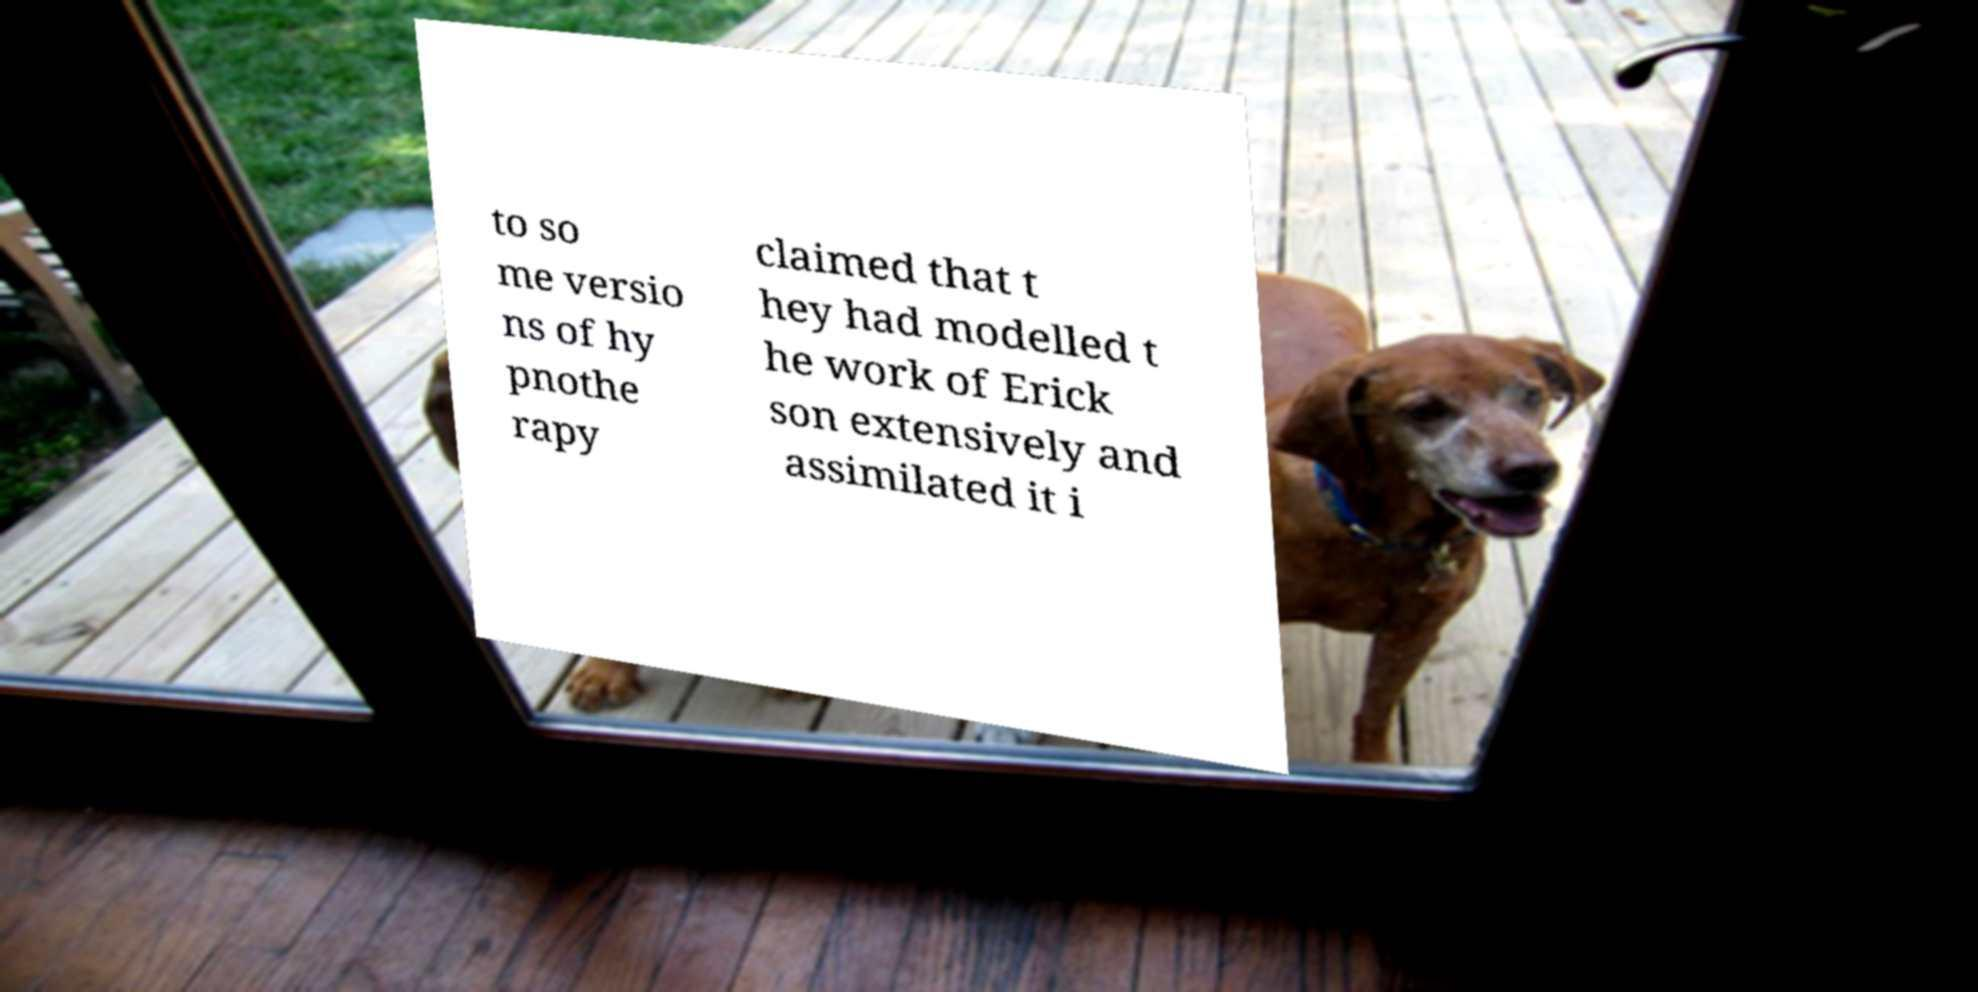Could you assist in decoding the text presented in this image and type it out clearly? to so me versio ns of hy pnothe rapy claimed that t hey had modelled t he work of Erick son extensively and assimilated it i 